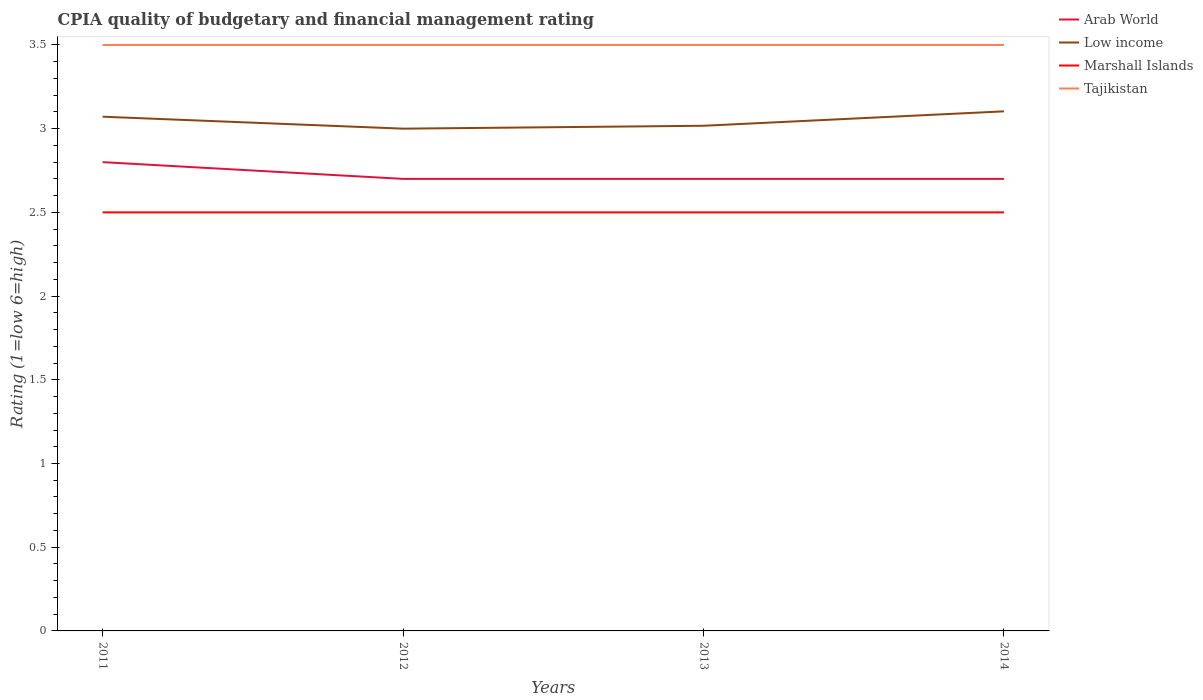How many different coloured lines are there?
Your answer should be very brief. 4. Does the line corresponding to Marshall Islands intersect with the line corresponding to Low income?
Offer a very short reply. No. Is the number of lines equal to the number of legend labels?
Offer a very short reply. Yes. Across all years, what is the maximum CPIA rating in Low income?
Offer a terse response. 3. In which year was the CPIA rating in Low income maximum?
Keep it short and to the point. 2012. What is the total CPIA rating in Arab World in the graph?
Offer a very short reply. 0.1. What is the difference between the highest and the second highest CPIA rating in Tajikistan?
Give a very brief answer. 0. What is the difference between the highest and the lowest CPIA rating in Marshall Islands?
Offer a very short reply. 0. Is the CPIA rating in Marshall Islands strictly greater than the CPIA rating in Arab World over the years?
Keep it short and to the point. Yes. What is the difference between two consecutive major ticks on the Y-axis?
Provide a succinct answer. 0.5. How many legend labels are there?
Your response must be concise. 4. What is the title of the graph?
Your answer should be compact. CPIA quality of budgetary and financial management rating. Does "Guatemala" appear as one of the legend labels in the graph?
Offer a very short reply. No. What is the Rating (1=low 6=high) of Low income in 2011?
Provide a succinct answer. 3.07. What is the Rating (1=low 6=high) in Tajikistan in 2011?
Offer a terse response. 3.5. What is the Rating (1=low 6=high) of Low income in 2012?
Give a very brief answer. 3. What is the Rating (1=low 6=high) in Tajikistan in 2012?
Offer a terse response. 3.5. What is the Rating (1=low 6=high) of Arab World in 2013?
Ensure brevity in your answer.  2.7. What is the Rating (1=low 6=high) in Low income in 2013?
Your response must be concise. 3.02. What is the Rating (1=low 6=high) in Tajikistan in 2013?
Your response must be concise. 3.5. What is the Rating (1=low 6=high) of Low income in 2014?
Provide a succinct answer. 3.1. What is the Rating (1=low 6=high) in Tajikistan in 2014?
Keep it short and to the point. 3.5. Across all years, what is the maximum Rating (1=low 6=high) of Arab World?
Your answer should be very brief. 2.8. Across all years, what is the maximum Rating (1=low 6=high) in Low income?
Your answer should be very brief. 3.1. Across all years, what is the minimum Rating (1=low 6=high) in Arab World?
Your answer should be compact. 2.7. Across all years, what is the minimum Rating (1=low 6=high) of Low income?
Make the answer very short. 3. Across all years, what is the minimum Rating (1=low 6=high) of Marshall Islands?
Offer a terse response. 2.5. Across all years, what is the minimum Rating (1=low 6=high) in Tajikistan?
Your answer should be compact. 3.5. What is the total Rating (1=low 6=high) of Arab World in the graph?
Provide a succinct answer. 10.9. What is the total Rating (1=low 6=high) in Low income in the graph?
Provide a succinct answer. 12.19. What is the total Rating (1=low 6=high) in Tajikistan in the graph?
Ensure brevity in your answer.  14. What is the difference between the Rating (1=low 6=high) in Arab World in 2011 and that in 2012?
Offer a terse response. 0.1. What is the difference between the Rating (1=low 6=high) in Low income in 2011 and that in 2012?
Provide a succinct answer. 0.07. What is the difference between the Rating (1=low 6=high) in Marshall Islands in 2011 and that in 2012?
Give a very brief answer. 0. What is the difference between the Rating (1=low 6=high) of Tajikistan in 2011 and that in 2012?
Offer a terse response. 0. What is the difference between the Rating (1=low 6=high) in Low income in 2011 and that in 2013?
Provide a succinct answer. 0.05. What is the difference between the Rating (1=low 6=high) of Tajikistan in 2011 and that in 2013?
Offer a terse response. 0. What is the difference between the Rating (1=low 6=high) in Low income in 2011 and that in 2014?
Your answer should be compact. -0.03. What is the difference between the Rating (1=low 6=high) of Low income in 2012 and that in 2013?
Provide a succinct answer. -0.02. What is the difference between the Rating (1=low 6=high) in Marshall Islands in 2012 and that in 2013?
Your response must be concise. 0. What is the difference between the Rating (1=low 6=high) of Arab World in 2012 and that in 2014?
Ensure brevity in your answer.  0. What is the difference between the Rating (1=low 6=high) of Low income in 2012 and that in 2014?
Provide a short and direct response. -0.1. What is the difference between the Rating (1=low 6=high) in Arab World in 2013 and that in 2014?
Offer a terse response. 0. What is the difference between the Rating (1=low 6=high) of Low income in 2013 and that in 2014?
Offer a very short reply. -0.09. What is the difference between the Rating (1=low 6=high) of Marshall Islands in 2013 and that in 2014?
Your response must be concise. 0. What is the difference between the Rating (1=low 6=high) of Low income in 2011 and the Rating (1=low 6=high) of Tajikistan in 2012?
Your answer should be compact. -0.43. What is the difference between the Rating (1=low 6=high) in Marshall Islands in 2011 and the Rating (1=low 6=high) in Tajikistan in 2012?
Your answer should be compact. -1. What is the difference between the Rating (1=low 6=high) in Arab World in 2011 and the Rating (1=low 6=high) in Low income in 2013?
Keep it short and to the point. -0.22. What is the difference between the Rating (1=low 6=high) in Arab World in 2011 and the Rating (1=low 6=high) in Tajikistan in 2013?
Your answer should be very brief. -0.7. What is the difference between the Rating (1=low 6=high) of Low income in 2011 and the Rating (1=low 6=high) of Tajikistan in 2013?
Your answer should be very brief. -0.43. What is the difference between the Rating (1=low 6=high) of Arab World in 2011 and the Rating (1=low 6=high) of Low income in 2014?
Give a very brief answer. -0.3. What is the difference between the Rating (1=low 6=high) in Arab World in 2011 and the Rating (1=low 6=high) in Marshall Islands in 2014?
Your answer should be compact. 0.3. What is the difference between the Rating (1=low 6=high) of Arab World in 2011 and the Rating (1=low 6=high) of Tajikistan in 2014?
Keep it short and to the point. -0.7. What is the difference between the Rating (1=low 6=high) in Low income in 2011 and the Rating (1=low 6=high) in Tajikistan in 2014?
Offer a terse response. -0.43. What is the difference between the Rating (1=low 6=high) in Marshall Islands in 2011 and the Rating (1=low 6=high) in Tajikistan in 2014?
Your answer should be compact. -1. What is the difference between the Rating (1=low 6=high) in Arab World in 2012 and the Rating (1=low 6=high) in Low income in 2013?
Your answer should be compact. -0.32. What is the difference between the Rating (1=low 6=high) in Arab World in 2012 and the Rating (1=low 6=high) in Tajikistan in 2013?
Keep it short and to the point. -0.8. What is the difference between the Rating (1=low 6=high) in Low income in 2012 and the Rating (1=low 6=high) in Marshall Islands in 2013?
Make the answer very short. 0.5. What is the difference between the Rating (1=low 6=high) of Low income in 2012 and the Rating (1=low 6=high) of Tajikistan in 2013?
Make the answer very short. -0.5. What is the difference between the Rating (1=low 6=high) of Marshall Islands in 2012 and the Rating (1=low 6=high) of Tajikistan in 2013?
Offer a terse response. -1. What is the difference between the Rating (1=low 6=high) of Arab World in 2012 and the Rating (1=low 6=high) of Low income in 2014?
Your answer should be very brief. -0.4. What is the difference between the Rating (1=low 6=high) of Arab World in 2012 and the Rating (1=low 6=high) of Marshall Islands in 2014?
Provide a succinct answer. 0.2. What is the difference between the Rating (1=low 6=high) in Arab World in 2013 and the Rating (1=low 6=high) in Low income in 2014?
Your response must be concise. -0.4. What is the difference between the Rating (1=low 6=high) in Arab World in 2013 and the Rating (1=low 6=high) in Tajikistan in 2014?
Your answer should be compact. -0.8. What is the difference between the Rating (1=low 6=high) of Low income in 2013 and the Rating (1=low 6=high) of Marshall Islands in 2014?
Provide a succinct answer. 0.52. What is the difference between the Rating (1=low 6=high) in Low income in 2013 and the Rating (1=low 6=high) in Tajikistan in 2014?
Offer a terse response. -0.48. What is the difference between the Rating (1=low 6=high) of Marshall Islands in 2013 and the Rating (1=low 6=high) of Tajikistan in 2014?
Ensure brevity in your answer.  -1. What is the average Rating (1=low 6=high) in Arab World per year?
Provide a short and direct response. 2.73. What is the average Rating (1=low 6=high) in Low income per year?
Keep it short and to the point. 3.05. What is the average Rating (1=low 6=high) in Tajikistan per year?
Provide a succinct answer. 3.5. In the year 2011, what is the difference between the Rating (1=low 6=high) in Arab World and Rating (1=low 6=high) in Low income?
Your answer should be compact. -0.27. In the year 2011, what is the difference between the Rating (1=low 6=high) in Arab World and Rating (1=low 6=high) in Marshall Islands?
Your answer should be compact. 0.3. In the year 2011, what is the difference between the Rating (1=low 6=high) in Low income and Rating (1=low 6=high) in Tajikistan?
Provide a short and direct response. -0.43. In the year 2011, what is the difference between the Rating (1=low 6=high) in Marshall Islands and Rating (1=low 6=high) in Tajikistan?
Your answer should be compact. -1. In the year 2012, what is the difference between the Rating (1=low 6=high) in Arab World and Rating (1=low 6=high) in Marshall Islands?
Provide a short and direct response. 0.2. In the year 2012, what is the difference between the Rating (1=low 6=high) of Low income and Rating (1=low 6=high) of Marshall Islands?
Make the answer very short. 0.5. In the year 2012, what is the difference between the Rating (1=low 6=high) in Low income and Rating (1=low 6=high) in Tajikistan?
Make the answer very short. -0.5. In the year 2013, what is the difference between the Rating (1=low 6=high) of Arab World and Rating (1=low 6=high) of Low income?
Make the answer very short. -0.32. In the year 2013, what is the difference between the Rating (1=low 6=high) in Low income and Rating (1=low 6=high) in Marshall Islands?
Offer a terse response. 0.52. In the year 2013, what is the difference between the Rating (1=low 6=high) of Low income and Rating (1=low 6=high) of Tajikistan?
Your answer should be very brief. -0.48. In the year 2014, what is the difference between the Rating (1=low 6=high) of Arab World and Rating (1=low 6=high) of Low income?
Ensure brevity in your answer.  -0.4. In the year 2014, what is the difference between the Rating (1=low 6=high) in Low income and Rating (1=low 6=high) in Marshall Islands?
Provide a succinct answer. 0.6. In the year 2014, what is the difference between the Rating (1=low 6=high) of Low income and Rating (1=low 6=high) of Tajikistan?
Your answer should be compact. -0.4. What is the ratio of the Rating (1=low 6=high) in Low income in 2011 to that in 2012?
Your answer should be very brief. 1.02. What is the ratio of the Rating (1=low 6=high) of Tajikistan in 2011 to that in 2012?
Offer a very short reply. 1. What is the ratio of the Rating (1=low 6=high) of Arab World in 2011 to that in 2013?
Your answer should be very brief. 1.04. What is the ratio of the Rating (1=low 6=high) in Marshall Islands in 2011 to that in 2013?
Provide a succinct answer. 1. What is the ratio of the Rating (1=low 6=high) of Tajikistan in 2011 to that in 2013?
Make the answer very short. 1. What is the ratio of the Rating (1=low 6=high) in Arab World in 2011 to that in 2014?
Ensure brevity in your answer.  1.04. What is the ratio of the Rating (1=low 6=high) in Marshall Islands in 2011 to that in 2014?
Provide a succinct answer. 1. What is the ratio of the Rating (1=low 6=high) in Low income in 2012 to that in 2013?
Offer a very short reply. 0.99. What is the ratio of the Rating (1=low 6=high) in Marshall Islands in 2012 to that in 2013?
Give a very brief answer. 1. What is the ratio of the Rating (1=low 6=high) of Arab World in 2012 to that in 2014?
Keep it short and to the point. 1. What is the ratio of the Rating (1=low 6=high) in Low income in 2012 to that in 2014?
Your answer should be very brief. 0.97. What is the ratio of the Rating (1=low 6=high) of Tajikistan in 2012 to that in 2014?
Offer a very short reply. 1. What is the ratio of the Rating (1=low 6=high) in Arab World in 2013 to that in 2014?
Ensure brevity in your answer.  1. What is the ratio of the Rating (1=low 6=high) of Low income in 2013 to that in 2014?
Your answer should be compact. 0.97. What is the ratio of the Rating (1=low 6=high) in Marshall Islands in 2013 to that in 2014?
Offer a terse response. 1. What is the ratio of the Rating (1=low 6=high) of Tajikistan in 2013 to that in 2014?
Provide a short and direct response. 1. What is the difference between the highest and the second highest Rating (1=low 6=high) in Arab World?
Keep it short and to the point. 0.1. What is the difference between the highest and the second highest Rating (1=low 6=high) in Low income?
Offer a very short reply. 0.03. What is the difference between the highest and the second highest Rating (1=low 6=high) in Marshall Islands?
Offer a terse response. 0. What is the difference between the highest and the lowest Rating (1=low 6=high) in Low income?
Keep it short and to the point. 0.1. What is the difference between the highest and the lowest Rating (1=low 6=high) in Marshall Islands?
Ensure brevity in your answer.  0. 